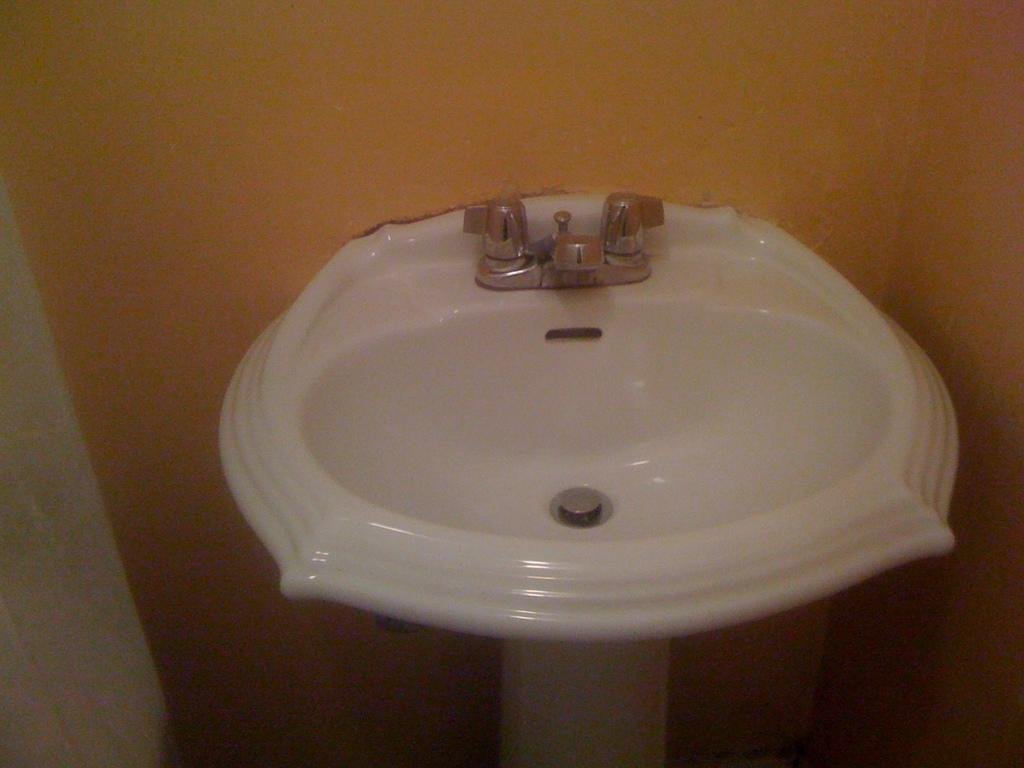What type of space is depicted in the image? The image is of a room. What can be found in the room? There is a wash basin in the room. How many taps are on the wash basin? There are two taps on the wash basin. What is located at the back of the room? There is a wall at the back of the room. How many centimeters is the pet in the image? There is no pet present in the image. What type of water is visible in the image? There is no water visible in the image. 